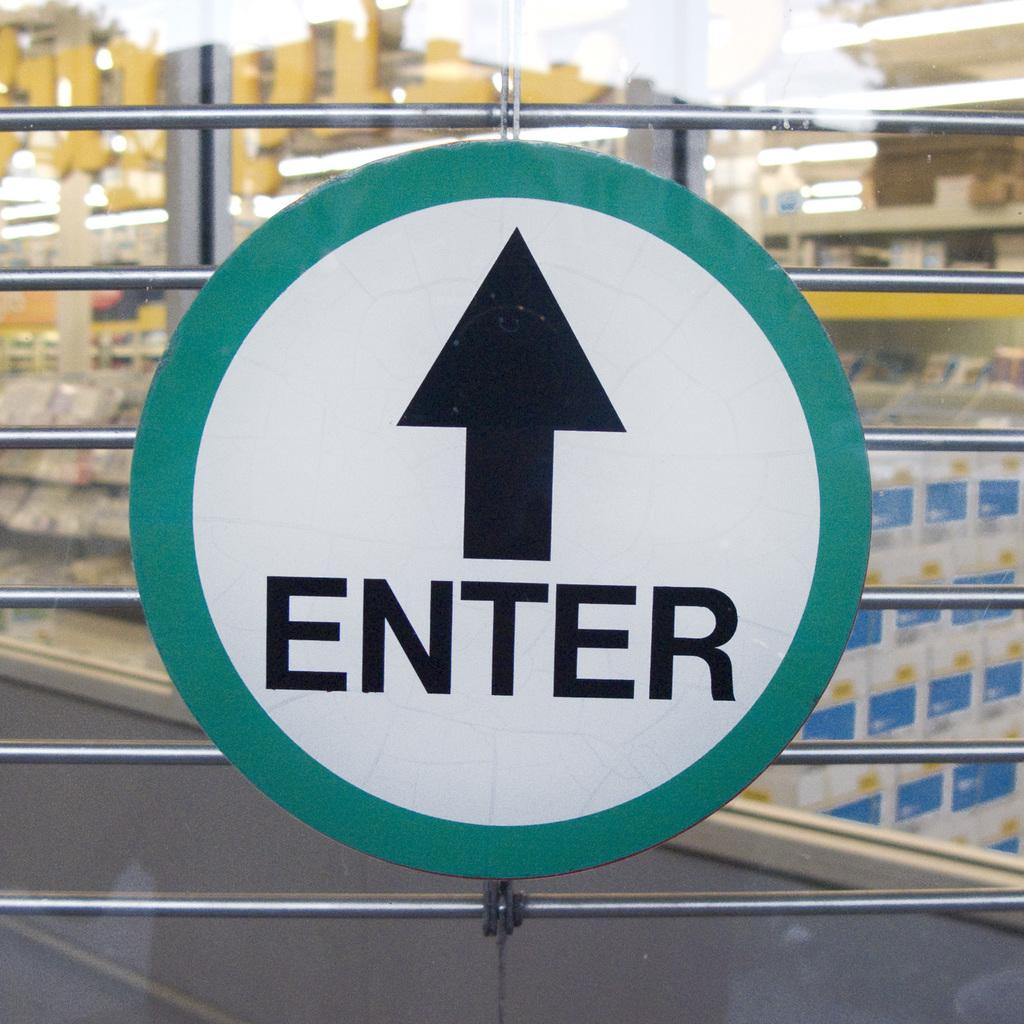What does the sign say you can do?
Provide a short and direct response. Enter. 